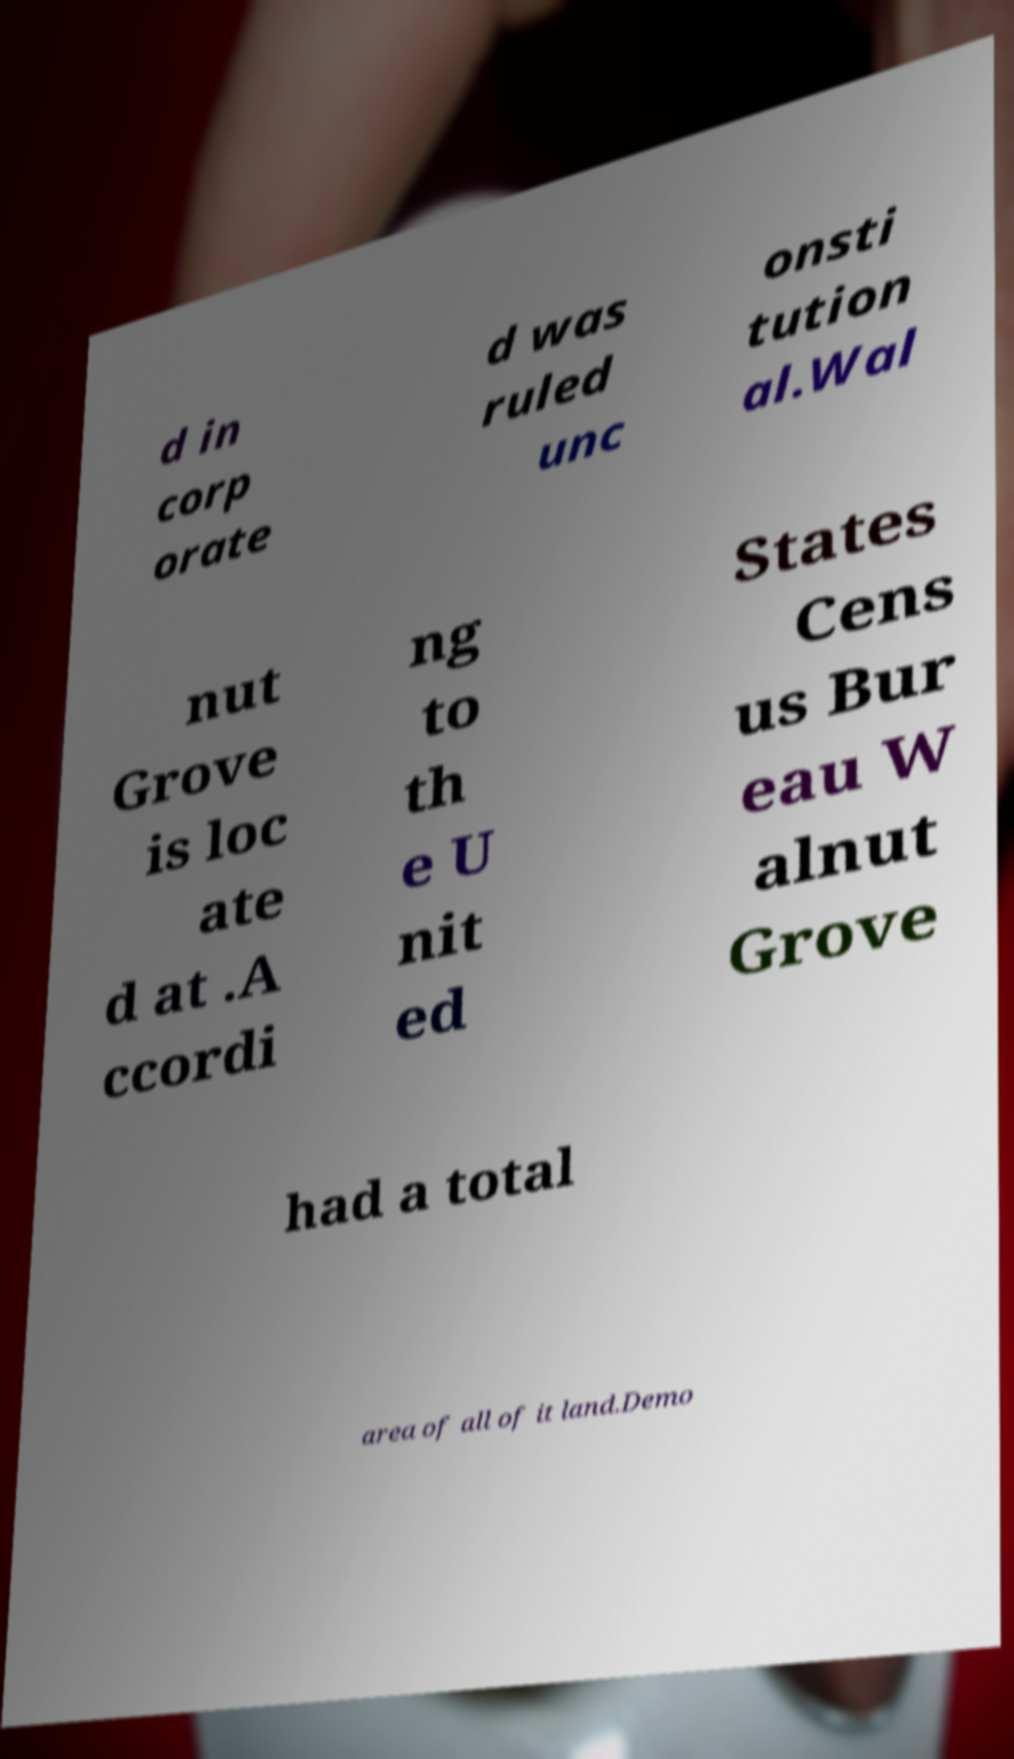Please identify and transcribe the text found in this image. d in corp orate d was ruled unc onsti tution al.Wal nut Grove is loc ate d at .A ccordi ng to th e U nit ed States Cens us Bur eau W alnut Grove had a total area of all of it land.Demo 